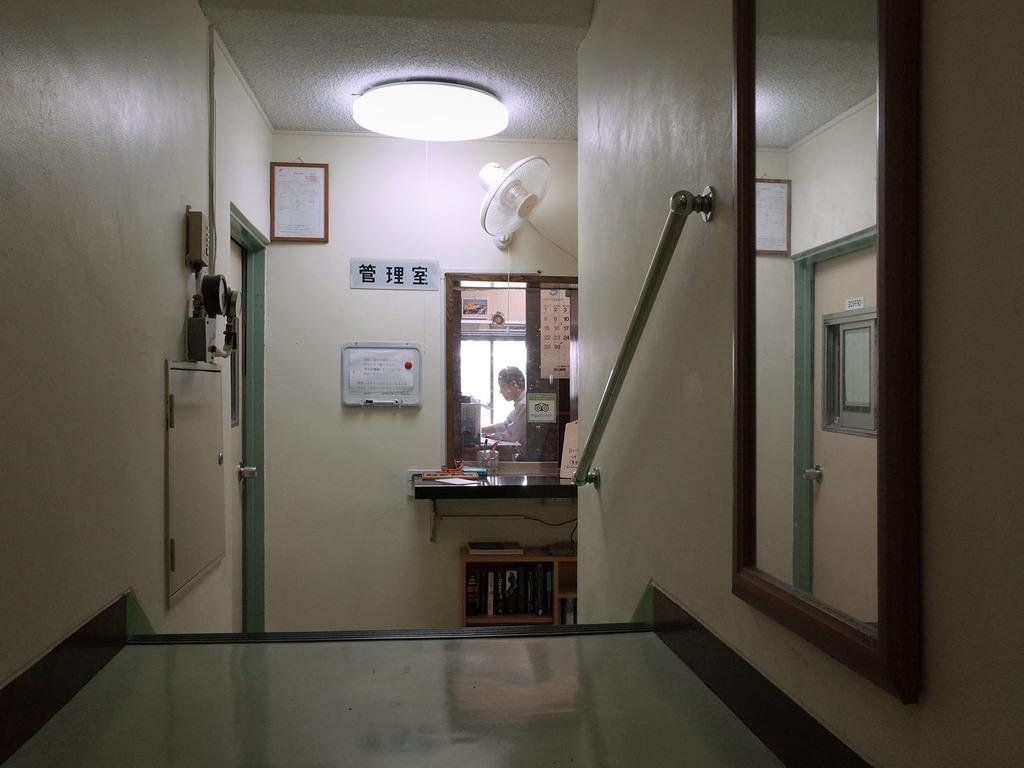What is located at the top of the image? There is a light at the top of the image. What is in the middle of the image? There is a mirror in the middle of the image. Are there any other mirrors in the image? Yes, there is a mirror on the right side of the image. What is present at the top of the image besides the light? There is a frame at the top of the image. Can you describe the person visible in one of the mirrors? Unfortunately, the facts provided do not give any information about the person visible in the mirror. What type of gun is being covered by the light in the image? There is no gun present in the image; it only features a light, mirrors, and a frame. 